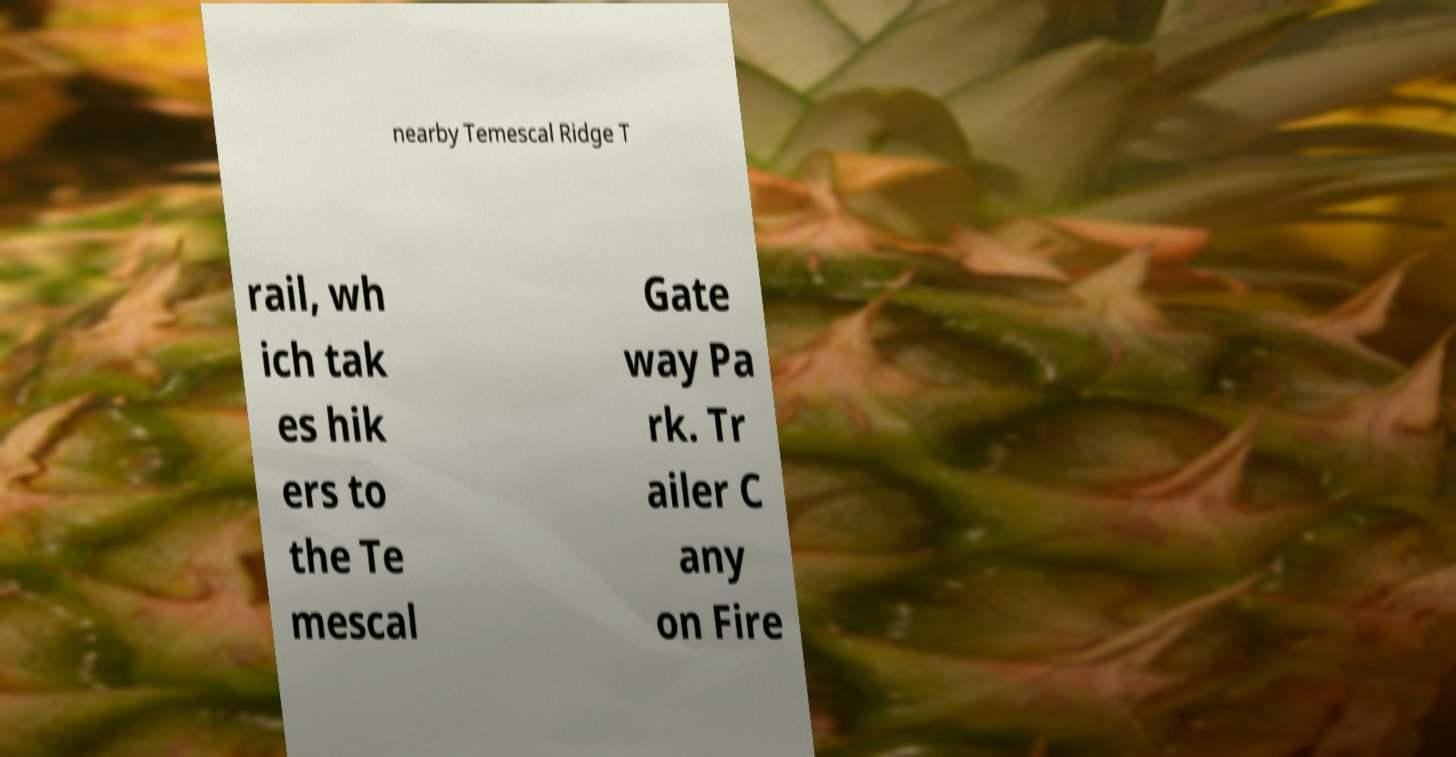For documentation purposes, I need the text within this image transcribed. Could you provide that? nearby Temescal Ridge T rail, wh ich tak es hik ers to the Te mescal Gate way Pa rk. Tr ailer C any on Fire 